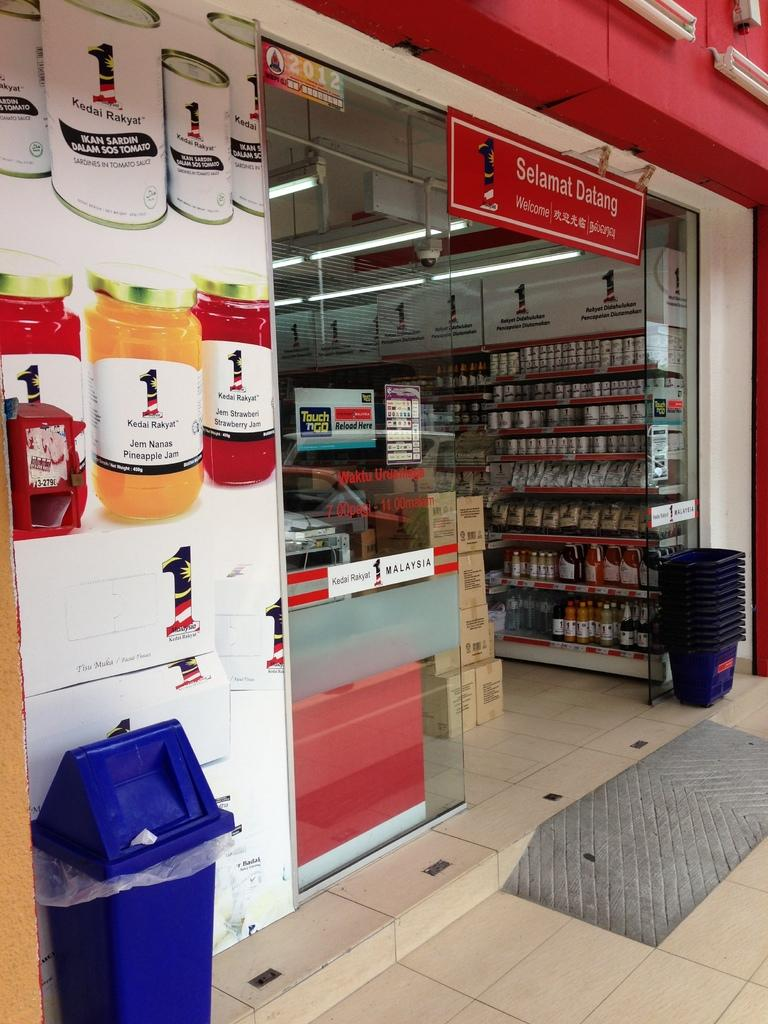<image>
Present a compact description of the photo's key features. A store front has glass doors that are open under a sign that says Selamat Datang. 